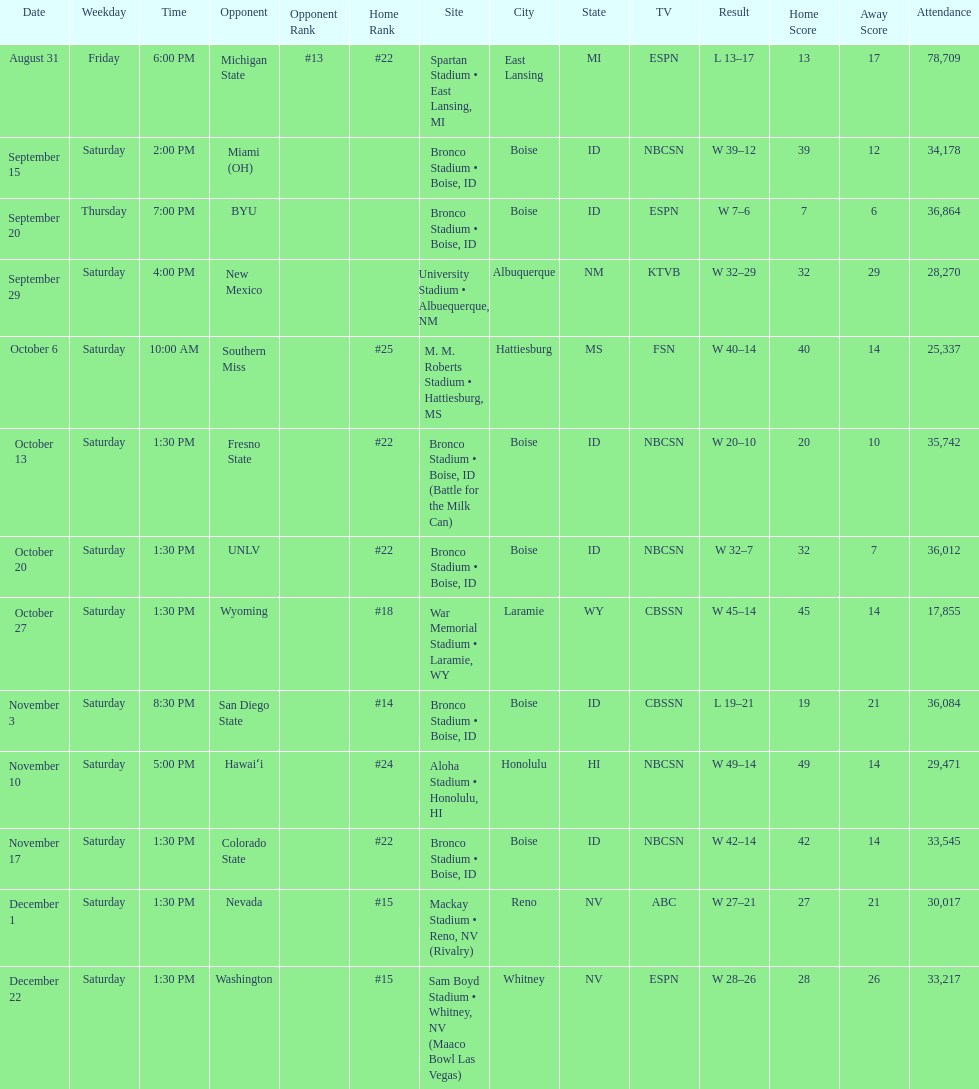What are the opponent teams of the 2012 boise state broncos football team? At #13 michigan state*, miami (oh)*, byu*, at new mexico, at southern miss*, fresno state, unlv, at wyoming, san diego state, at hawaiʻi, colorado state, at nevada, vs. washington*. How has the highest rank of these opponents? San Diego State. 